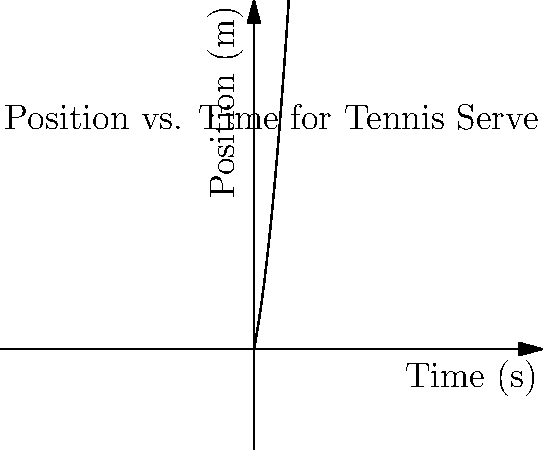As a former professional tennis player, you're analyzing the position-time graph of a tennis serve. The graph shows the ball's position (in meters) as a function of time (in seconds) after leaving the racket. Using the graph, calculate the average velocity of the ball during the first 2 seconds of its flight. To calculate the average velocity, we need to follow these steps:

1. Recall the formula for average velocity:
   $$v_{avg} = \frac{\Delta x}{\Delta t}$$
   where $\Delta x$ is the change in position and $\Delta t$ is the change in time.

2. Identify the initial and final positions:
   - At $t = 0$ s, $x_0 = f(0) = 2(0)^2 + 5(0) = 0$ m
   - At $t = 2$ s, $x_f = f(2) = 2(2)^2 + 5(2) = 18$ m

3. Calculate $\Delta x$:
   $$\Delta x = x_f - x_0 = 18 - 0 = 18\text{ m}$$

4. Identify $\Delta t$:
   $$\Delta t = 2\text{ s} - 0\text{ s} = 2\text{ s}$$

5. Apply the average velocity formula:
   $$v_{avg} = \frac{\Delta x}{\Delta t} = \frac{18\text{ m}}{2\text{ s}} = 9\text{ m/s}$$

Therefore, the average velocity of the tennis ball during the first 2 seconds of its flight is 9 m/s.
Answer: 9 m/s 